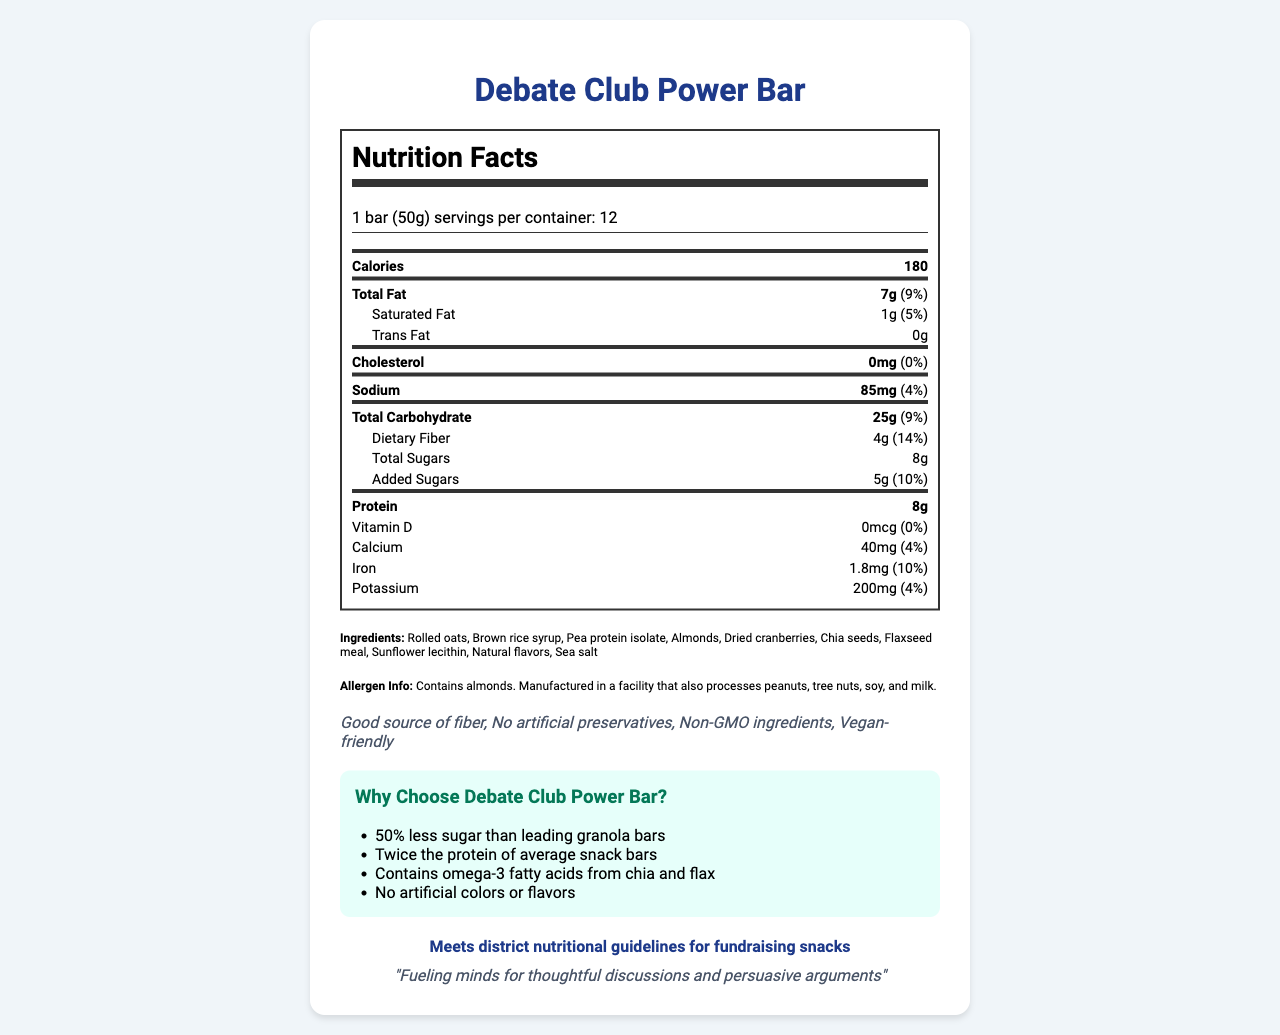what is the serving size of the Debate Club Power Bar? The serving size is explicitly stated as "1 bar (50g)."
Answer: 1 bar (50g) how many servings per container are there? The document states that there are 12 servings per container.
Answer: 12 how much protein does one Debate Club Power Bar contain? The nutrition label lists the protein content per serving as 8g.
Answer: 8g what is the daily value percentage of dietary fiber? The daily value percentage of dietary fiber is listed as 14%.
Answer: 14% what are the first three ingredients in the Debate Club Power Bar? The ingredients are listed in order, and the first three are Rolled oats, Brown rice syrup, and Pea protein isolate.
Answer: Rolled oats, Brown rice syrup, Pea protein isolate What is the total carbohydrate content in the bar? The nutrition label shows the total carbohydrate content as 25g.
Answer: 25g How much calcium is in one serving of the Debate Club Power Bar? A. 30mg B. 40mg C. 50mg D. 60mg The document states that one serving contains 40mg of calcium.
Answer: B Which of the following is a unique ingredient found in the Debate Club Power Bar? A. Soy protein isolate B. Almond butter C. Chia seeds D. Corn syrup The document includes chia seeds as an ingredient, which is unique among the given options.
Answer: C Does the Debate Club Power Bar meet the school district nutritional guidelines for fundraising snacks? The document states that the product meets district nutritional guidelines for fundraising snacks.
Answer: Yes Is the Debate Club Power Bar vegan-friendly? The health claims list "Vegan-friendly."
Answer: Yes What is the total amount of sugars in one bar? The total sugars are listed as 8g.
Answer: 8g Summarize the main idea of the document. The document details the nutritional content, ingredients, health claims, and benefits of the Debate Club Power Bar, highlighting its healthfulness and compliance with school guidelines.
Answer: The document provides detailed nutritional information about the Debate Club Power Bar, highlighting its healthy ingredients and nutritional benefits compared to other snack bars. It showcases its compliance with school district guidelines and includes a statement from the debate club. Are there any artificial preservatives in this product? The document claims there are "No artificial preservatives."
Answer: No How does the sugar content in Debate Club Power Bar compare to leading granola bars? Under comparison highlights, it states the bar has 50% less sugar than leading granola bars.
Answer: 50% less sugar What is the main source of protein in the Debate Club Power Bar? The ingredients list indicates that one of the main sources of protein is Pea protein isolate.
Answer: Pea protein isolate What are the health benefits of chia and flax in this snack? The document highlights that the product contains omega-3 fatty acids from chia and flax.
Answer: Contains omega-3 fatty acids How much saturated fat does one bar contain? The nutrition label lists saturated fat content as 1g.
Answer: 1g What is the purpose of the debate club statement in the document? The club statement "Fueling minds for thoughtful discussions and persuasive arguments" connects the nutritional benefits of the bar to the debate club’s goals.
Answer: To emphasize the bar's role in supporting debate activities How does the protein content compare to average snack bars? The document highlights that the Debate Club Power Bar has twice the protein of average snack bars.
Answer: Twice the protein What ingredient in the bar might be an allergen? The allergen info specifies that the product contains almonds.
Answer: Almonds What is the exact cholesterol content of the Debate Club Power Bar? The nutrition label lists the cholesterol content as 0mg.
Answer: 0mg How much iron does one serving provide as a percentage of the daily value? The document lists the iron content as 1.8mg, which is 10% of the daily value.
Answer: 10% What are the only preservatives found in the Debate Club Power Bar? The health claims explicitly state "No artificial preservatives."
Answer: None Does the nutrition facts panel include the amount of omega-3 fatty acids? The document mentions omega-3 fatty acids in the comparison highlights but does not include specific quantities in the nutrition facts.
Answer: No When were the Debate Club Power Bars first introduced? The document does not provide any information about the introduction date of the product.
Answer: Cannot be determined 